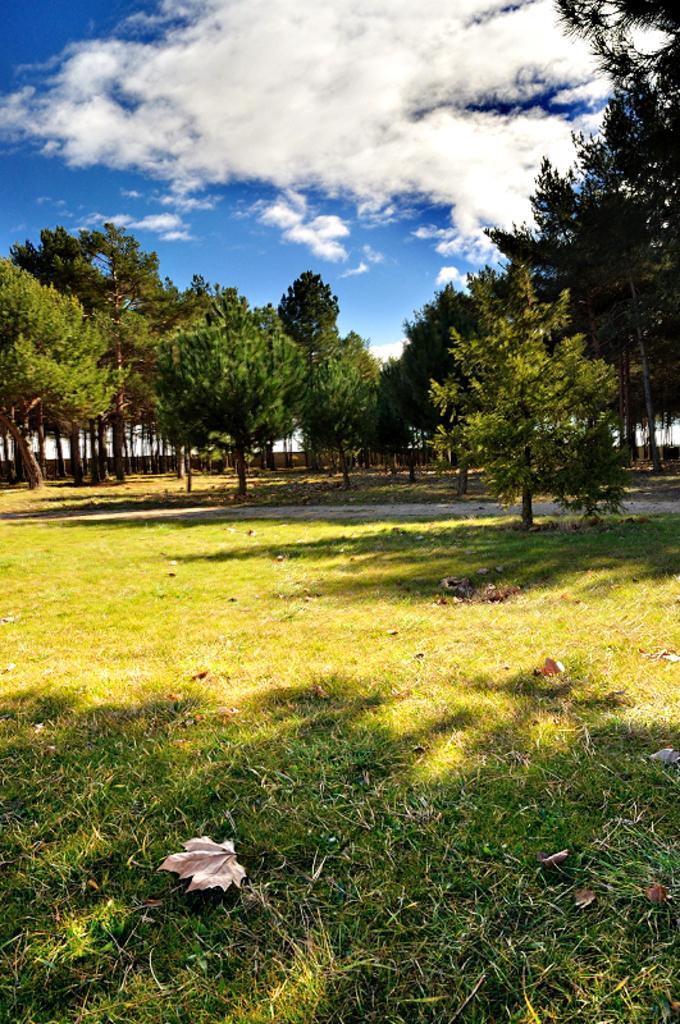Describe this image in one or two sentences. In this image there are trees in the middle. At the bottom there is grass on which there are dry leaves. At the top there is the sky with the clouds. 